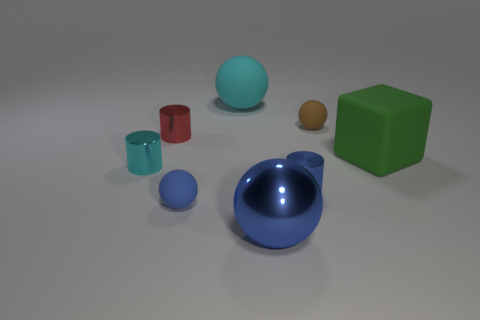Subtract all purple spheres. Subtract all green cubes. How many spheres are left? 4 Add 1 tiny brown matte balls. How many objects exist? 9 Subtract all blocks. How many objects are left? 7 Add 1 big blue things. How many big blue things exist? 2 Subtract 0 purple balls. How many objects are left? 8 Subtract all tiny purple matte objects. Subtract all brown objects. How many objects are left? 7 Add 4 tiny red shiny cylinders. How many tiny red shiny cylinders are left? 5 